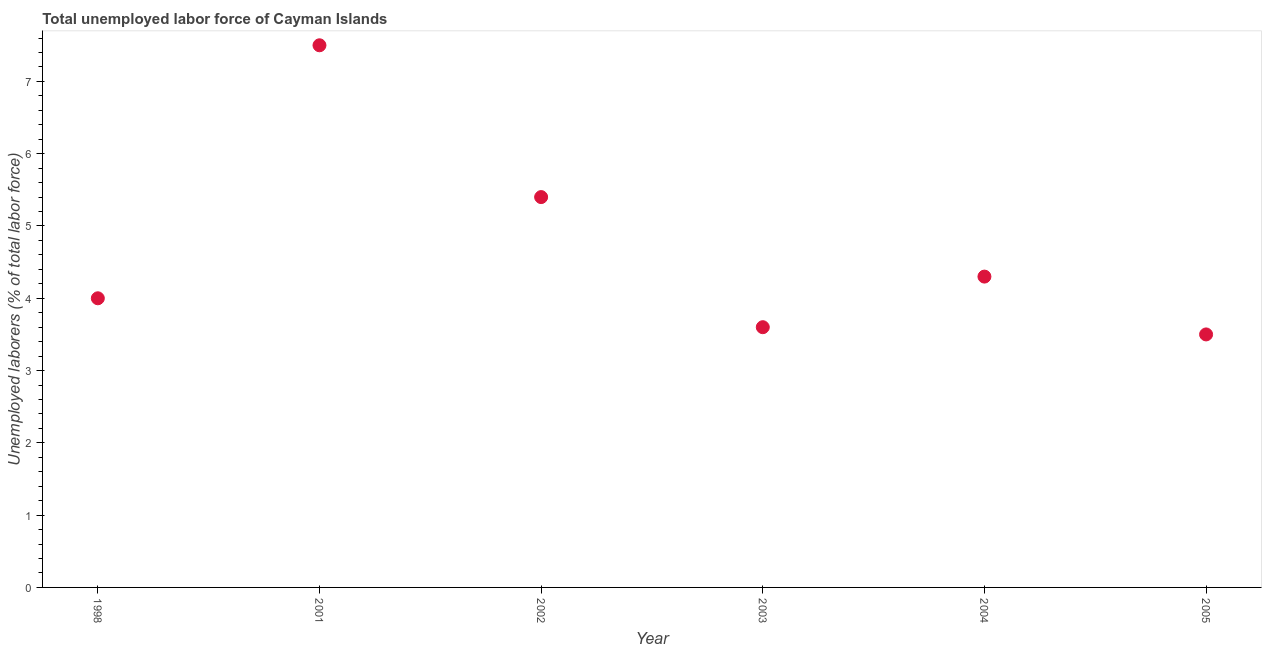What is the total unemployed labour force in 2002?
Offer a terse response. 5.4. In which year was the total unemployed labour force minimum?
Your answer should be compact. 2005. What is the sum of the total unemployed labour force?
Your response must be concise. 28.3. What is the difference between the total unemployed labour force in 1998 and 2002?
Your answer should be compact. -1.4. What is the average total unemployed labour force per year?
Your answer should be very brief. 4.72. What is the median total unemployed labour force?
Provide a short and direct response. 4.15. In how many years, is the total unemployed labour force greater than 4.4 %?
Your response must be concise. 2. What is the ratio of the total unemployed labour force in 2004 to that in 2005?
Ensure brevity in your answer.  1.23. What is the difference between the highest and the second highest total unemployed labour force?
Provide a short and direct response. 2.1. What is the difference between the highest and the lowest total unemployed labour force?
Your answer should be very brief. 4. Does the total unemployed labour force monotonically increase over the years?
Offer a very short reply. No. How many dotlines are there?
Your answer should be very brief. 1. Are the values on the major ticks of Y-axis written in scientific E-notation?
Your answer should be very brief. No. Does the graph contain grids?
Your response must be concise. No. What is the title of the graph?
Give a very brief answer. Total unemployed labor force of Cayman Islands. What is the label or title of the Y-axis?
Your answer should be compact. Unemployed laborers (% of total labor force). What is the Unemployed laborers (% of total labor force) in 1998?
Provide a short and direct response. 4. What is the Unemployed laborers (% of total labor force) in 2001?
Give a very brief answer. 7.5. What is the Unemployed laborers (% of total labor force) in 2002?
Your response must be concise. 5.4. What is the Unemployed laborers (% of total labor force) in 2003?
Offer a very short reply. 3.6. What is the Unemployed laborers (% of total labor force) in 2004?
Provide a succinct answer. 4.3. What is the Unemployed laborers (% of total labor force) in 2005?
Keep it short and to the point. 3.5. What is the difference between the Unemployed laborers (% of total labor force) in 1998 and 2003?
Your answer should be very brief. 0.4. What is the difference between the Unemployed laborers (% of total labor force) in 1998 and 2004?
Your answer should be compact. -0.3. What is the difference between the Unemployed laborers (% of total labor force) in 1998 and 2005?
Keep it short and to the point. 0.5. What is the difference between the Unemployed laborers (% of total labor force) in 2001 and 2003?
Ensure brevity in your answer.  3.9. What is the difference between the Unemployed laborers (% of total labor force) in 2001 and 2005?
Provide a succinct answer. 4. What is the difference between the Unemployed laborers (% of total labor force) in 2002 and 2003?
Provide a succinct answer. 1.8. What is the difference between the Unemployed laborers (% of total labor force) in 2003 and 2005?
Keep it short and to the point. 0.1. What is the ratio of the Unemployed laborers (% of total labor force) in 1998 to that in 2001?
Your response must be concise. 0.53. What is the ratio of the Unemployed laborers (% of total labor force) in 1998 to that in 2002?
Offer a terse response. 0.74. What is the ratio of the Unemployed laborers (% of total labor force) in 1998 to that in 2003?
Your answer should be compact. 1.11. What is the ratio of the Unemployed laborers (% of total labor force) in 1998 to that in 2005?
Make the answer very short. 1.14. What is the ratio of the Unemployed laborers (% of total labor force) in 2001 to that in 2002?
Provide a short and direct response. 1.39. What is the ratio of the Unemployed laborers (% of total labor force) in 2001 to that in 2003?
Your answer should be very brief. 2.08. What is the ratio of the Unemployed laborers (% of total labor force) in 2001 to that in 2004?
Give a very brief answer. 1.74. What is the ratio of the Unemployed laborers (% of total labor force) in 2001 to that in 2005?
Your answer should be compact. 2.14. What is the ratio of the Unemployed laborers (% of total labor force) in 2002 to that in 2003?
Offer a terse response. 1.5. What is the ratio of the Unemployed laborers (% of total labor force) in 2002 to that in 2004?
Your response must be concise. 1.26. What is the ratio of the Unemployed laborers (% of total labor force) in 2002 to that in 2005?
Your answer should be very brief. 1.54. What is the ratio of the Unemployed laborers (% of total labor force) in 2003 to that in 2004?
Give a very brief answer. 0.84. What is the ratio of the Unemployed laborers (% of total labor force) in 2004 to that in 2005?
Your answer should be compact. 1.23. 